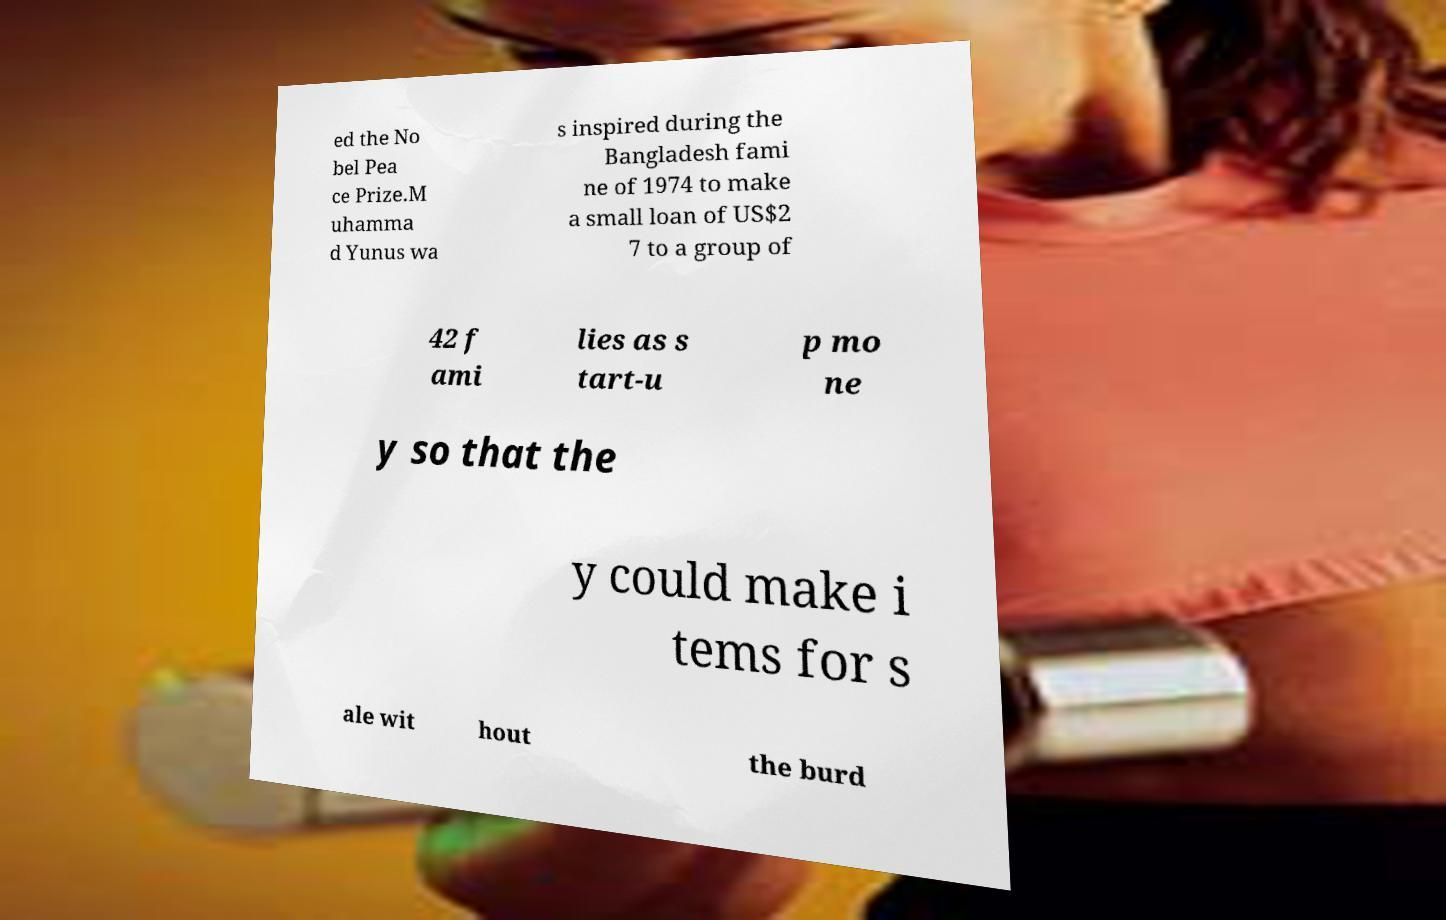I need the written content from this picture converted into text. Can you do that? ed the No bel Pea ce Prize.M uhamma d Yunus wa s inspired during the Bangladesh fami ne of 1974 to make a small loan of US$2 7 to a group of 42 f ami lies as s tart-u p mo ne y so that the y could make i tems for s ale wit hout the burd 